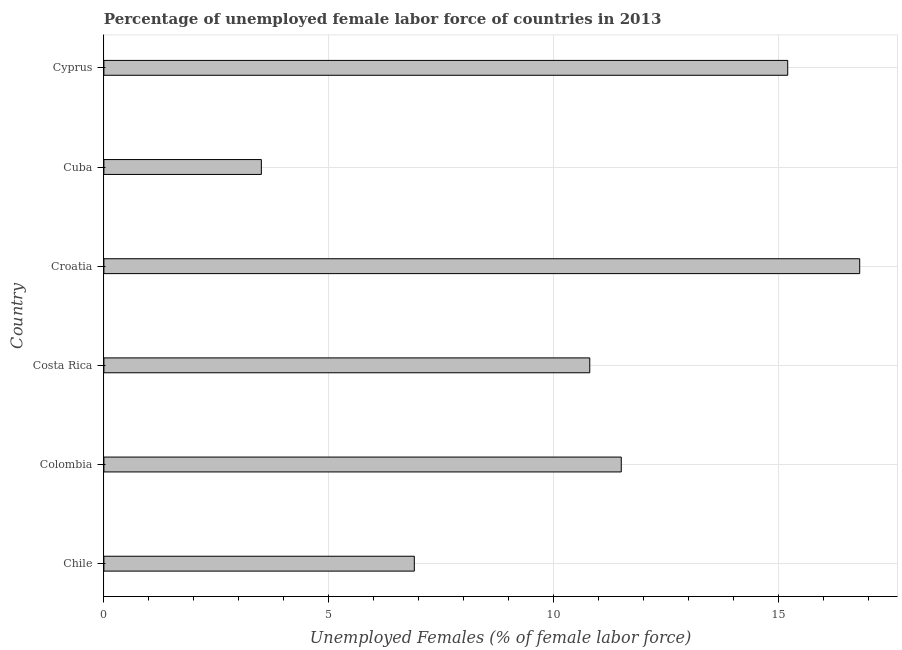Does the graph contain any zero values?
Your response must be concise. No. What is the title of the graph?
Ensure brevity in your answer.  Percentage of unemployed female labor force of countries in 2013. What is the label or title of the X-axis?
Make the answer very short. Unemployed Females (% of female labor force). What is the label or title of the Y-axis?
Keep it short and to the point. Country. What is the total unemployed female labour force in Cuba?
Keep it short and to the point. 3.5. Across all countries, what is the maximum total unemployed female labour force?
Ensure brevity in your answer.  16.8. In which country was the total unemployed female labour force maximum?
Give a very brief answer. Croatia. In which country was the total unemployed female labour force minimum?
Provide a succinct answer. Cuba. What is the sum of the total unemployed female labour force?
Offer a very short reply. 64.7. What is the average total unemployed female labour force per country?
Give a very brief answer. 10.78. What is the median total unemployed female labour force?
Your answer should be very brief. 11.15. In how many countries, is the total unemployed female labour force greater than 12 %?
Provide a short and direct response. 2. What is the ratio of the total unemployed female labour force in Chile to that in Colombia?
Give a very brief answer. 0.6. What is the difference between the highest and the second highest total unemployed female labour force?
Your response must be concise. 1.6. Is the sum of the total unemployed female labour force in Colombia and Costa Rica greater than the maximum total unemployed female labour force across all countries?
Make the answer very short. Yes. What is the difference between the highest and the lowest total unemployed female labour force?
Provide a succinct answer. 13.3. How many bars are there?
Your answer should be compact. 6. How many countries are there in the graph?
Provide a succinct answer. 6. Are the values on the major ticks of X-axis written in scientific E-notation?
Offer a terse response. No. What is the Unemployed Females (% of female labor force) of Chile?
Offer a terse response. 6.9. What is the Unemployed Females (% of female labor force) in Colombia?
Keep it short and to the point. 11.5. What is the Unemployed Females (% of female labor force) in Costa Rica?
Give a very brief answer. 10.8. What is the Unemployed Females (% of female labor force) of Croatia?
Ensure brevity in your answer.  16.8. What is the Unemployed Females (% of female labor force) of Cuba?
Keep it short and to the point. 3.5. What is the Unemployed Females (% of female labor force) of Cyprus?
Provide a short and direct response. 15.2. What is the difference between the Unemployed Females (% of female labor force) in Chile and Costa Rica?
Make the answer very short. -3.9. What is the difference between the Unemployed Females (% of female labor force) in Chile and Croatia?
Give a very brief answer. -9.9. What is the difference between the Unemployed Females (% of female labor force) in Chile and Cuba?
Your answer should be compact. 3.4. What is the difference between the Unemployed Females (% of female labor force) in Colombia and Costa Rica?
Your answer should be very brief. 0.7. What is the difference between the Unemployed Females (% of female labor force) in Costa Rica and Cuba?
Your answer should be compact. 7.3. What is the difference between the Unemployed Females (% of female labor force) in Croatia and Cuba?
Keep it short and to the point. 13.3. What is the difference between the Unemployed Females (% of female labor force) in Croatia and Cyprus?
Provide a succinct answer. 1.6. What is the difference between the Unemployed Females (% of female labor force) in Cuba and Cyprus?
Give a very brief answer. -11.7. What is the ratio of the Unemployed Females (% of female labor force) in Chile to that in Costa Rica?
Offer a very short reply. 0.64. What is the ratio of the Unemployed Females (% of female labor force) in Chile to that in Croatia?
Offer a terse response. 0.41. What is the ratio of the Unemployed Females (% of female labor force) in Chile to that in Cuba?
Your answer should be very brief. 1.97. What is the ratio of the Unemployed Females (% of female labor force) in Chile to that in Cyprus?
Make the answer very short. 0.45. What is the ratio of the Unemployed Females (% of female labor force) in Colombia to that in Costa Rica?
Your answer should be compact. 1.06. What is the ratio of the Unemployed Females (% of female labor force) in Colombia to that in Croatia?
Offer a terse response. 0.69. What is the ratio of the Unemployed Females (% of female labor force) in Colombia to that in Cuba?
Offer a terse response. 3.29. What is the ratio of the Unemployed Females (% of female labor force) in Colombia to that in Cyprus?
Your answer should be very brief. 0.76. What is the ratio of the Unemployed Females (% of female labor force) in Costa Rica to that in Croatia?
Your response must be concise. 0.64. What is the ratio of the Unemployed Females (% of female labor force) in Costa Rica to that in Cuba?
Your answer should be very brief. 3.09. What is the ratio of the Unemployed Females (% of female labor force) in Costa Rica to that in Cyprus?
Your answer should be very brief. 0.71. What is the ratio of the Unemployed Females (% of female labor force) in Croatia to that in Cyprus?
Give a very brief answer. 1.1. What is the ratio of the Unemployed Females (% of female labor force) in Cuba to that in Cyprus?
Make the answer very short. 0.23. 